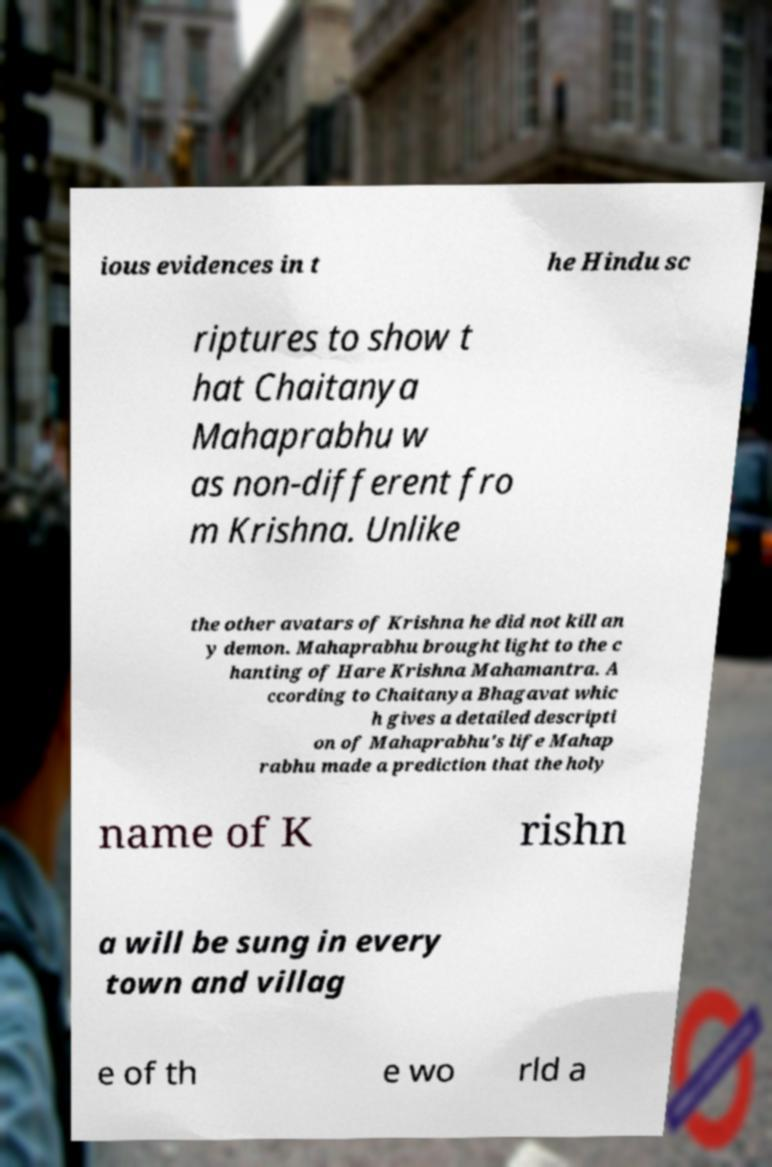Can you accurately transcribe the text from the provided image for me? ious evidences in t he Hindu sc riptures to show t hat Chaitanya Mahaprabhu w as non-different fro m Krishna. Unlike the other avatars of Krishna he did not kill an y demon. Mahaprabhu brought light to the c hanting of Hare Krishna Mahamantra. A ccording to Chaitanya Bhagavat whic h gives a detailed descripti on of Mahaprabhu's life Mahap rabhu made a prediction that the holy name of K rishn a will be sung in every town and villag e of th e wo rld a 